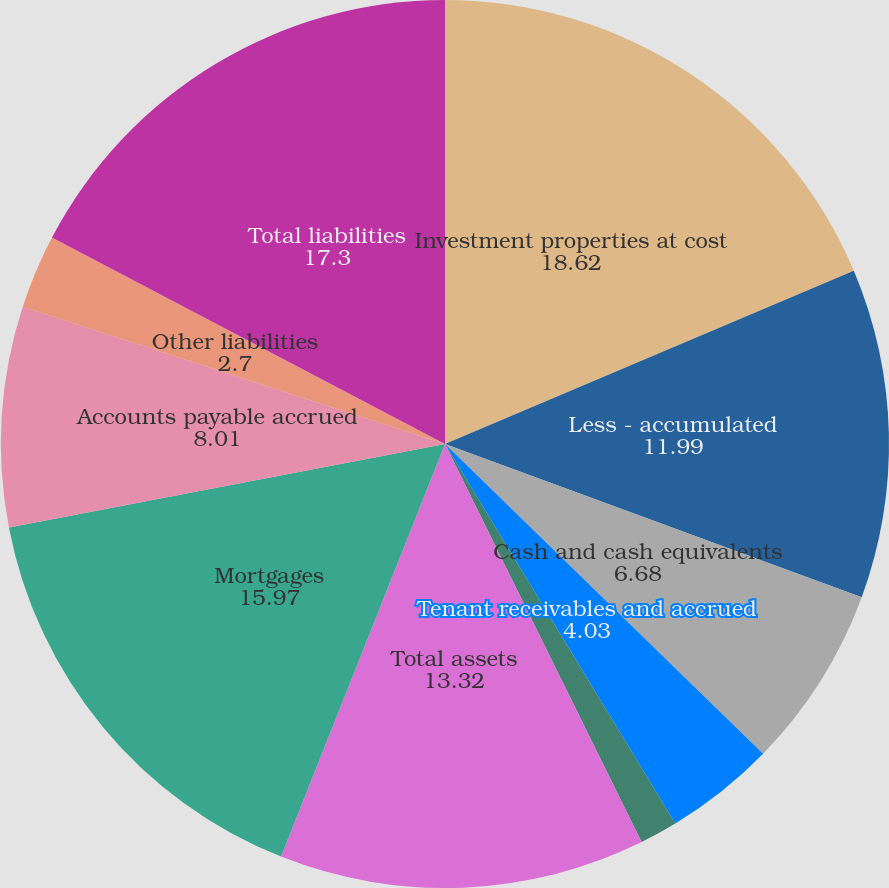<chart> <loc_0><loc_0><loc_500><loc_500><pie_chart><fcel>Investment properties at cost<fcel>Less - accumulated<fcel>Cash and cash equivalents<fcel>Tenant receivables and accrued<fcel>Deferred costs and other<fcel>Total assets<fcel>Mortgages<fcel>Accounts payable accrued<fcel>Other liabilities<fcel>Total liabilities<nl><fcel>18.62%<fcel>11.99%<fcel>6.68%<fcel>4.03%<fcel>1.38%<fcel>13.32%<fcel>15.97%<fcel>8.01%<fcel>2.7%<fcel>17.3%<nl></chart> 